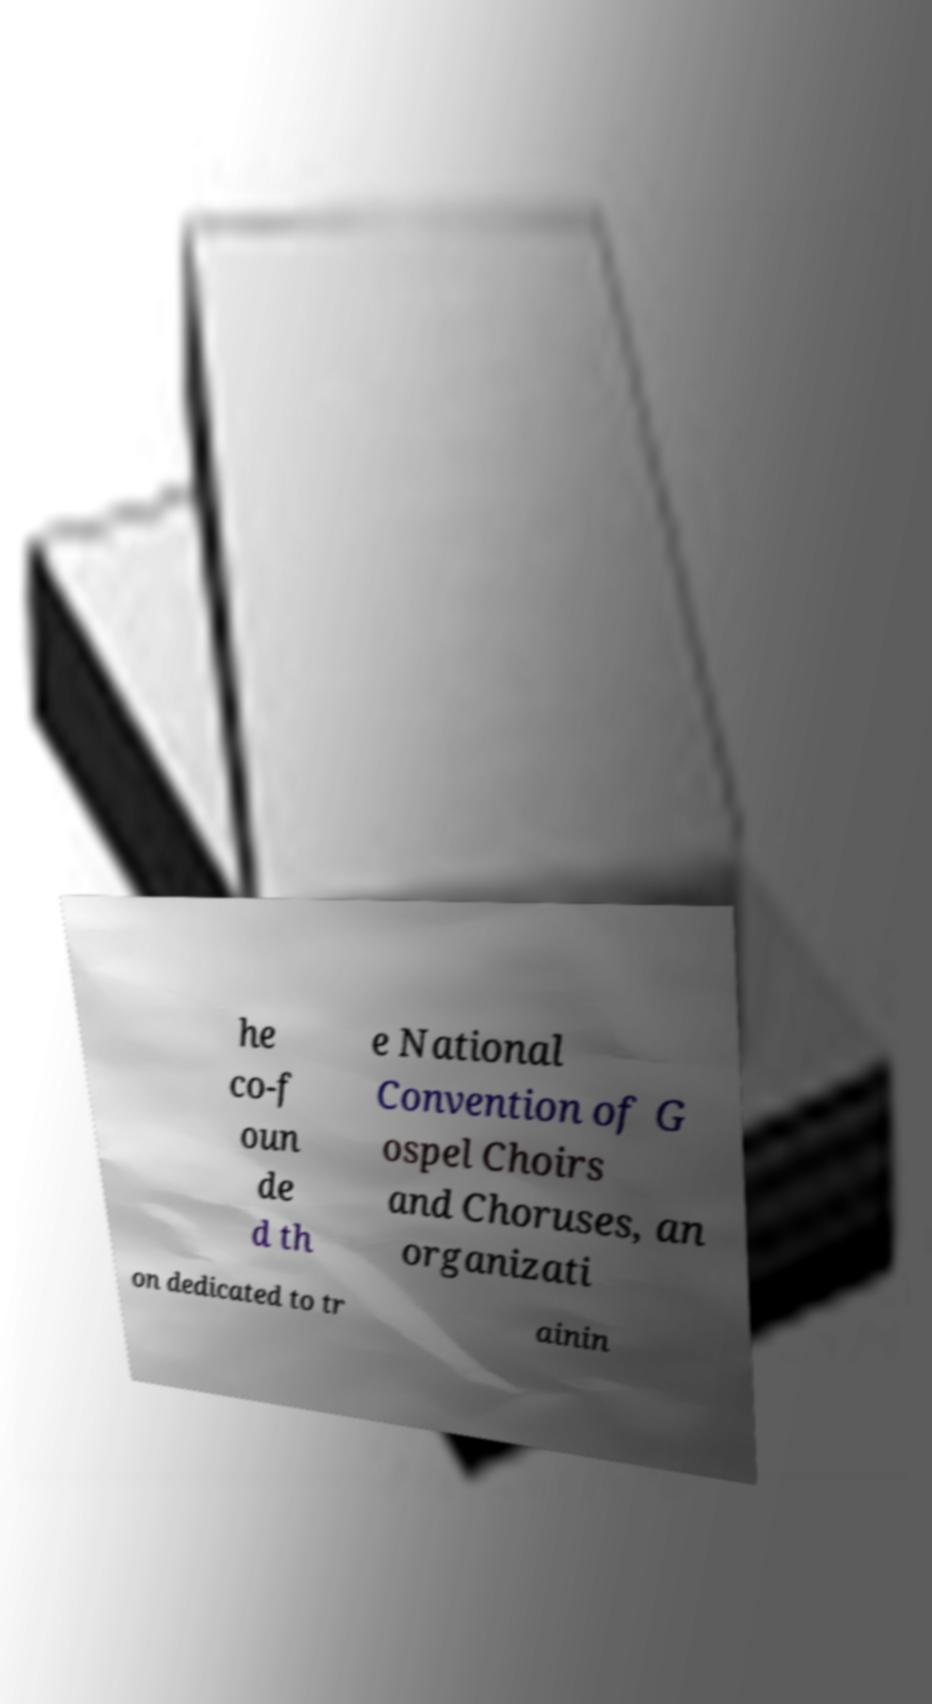I need the written content from this picture converted into text. Can you do that? he co-f oun de d th e National Convention of G ospel Choirs and Choruses, an organizati on dedicated to tr ainin 